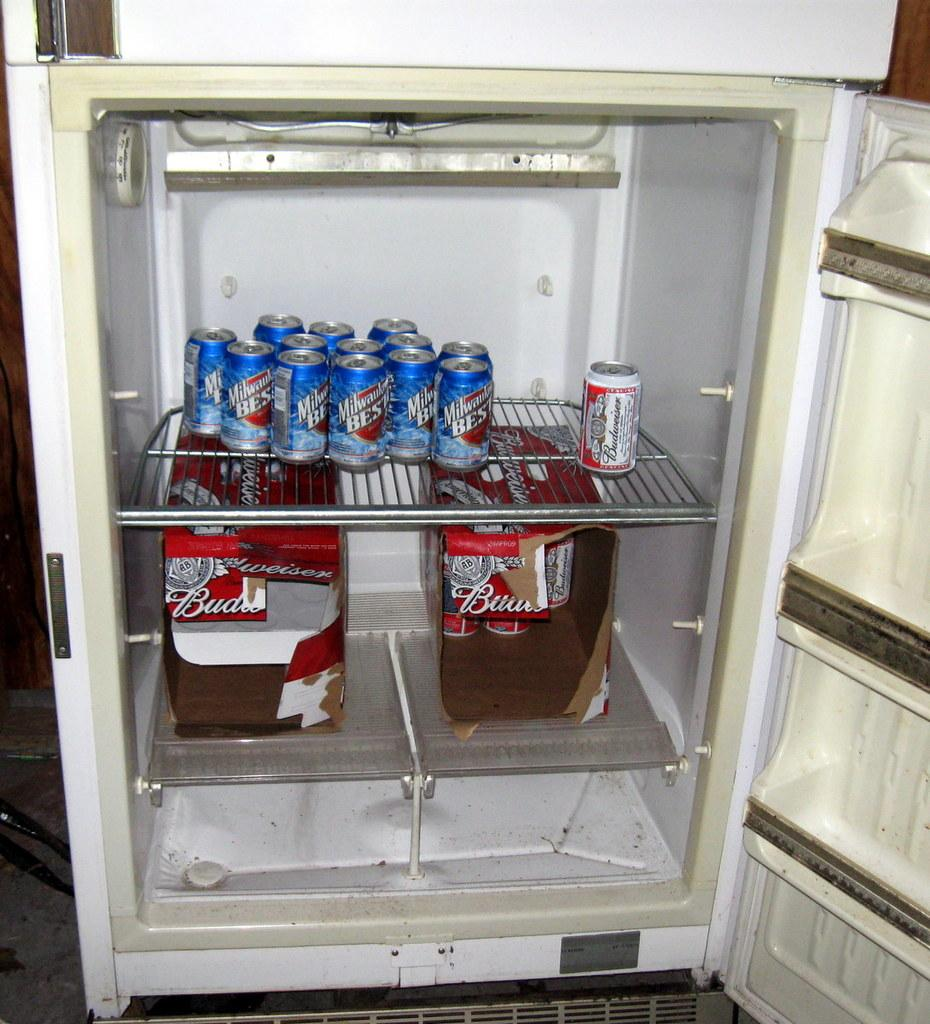<image>
Share a concise interpretation of the image provided. an open fridge with cans of milwaukee best in it 